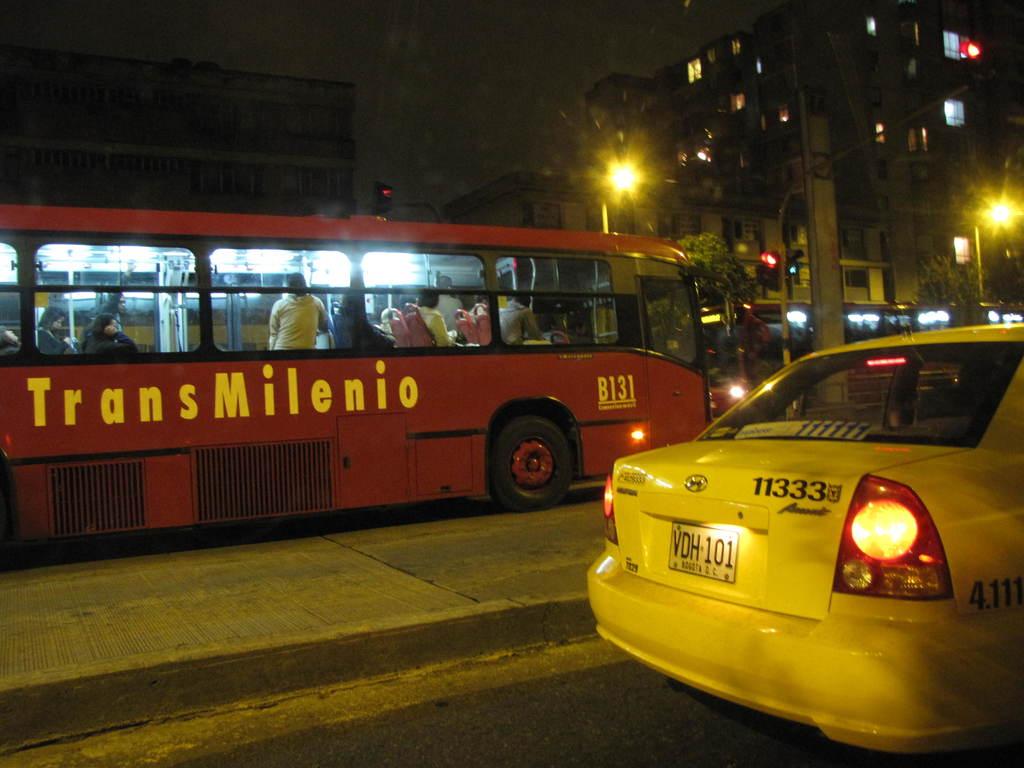What is the name of the bus?
Offer a very short reply. Transmilenio. 